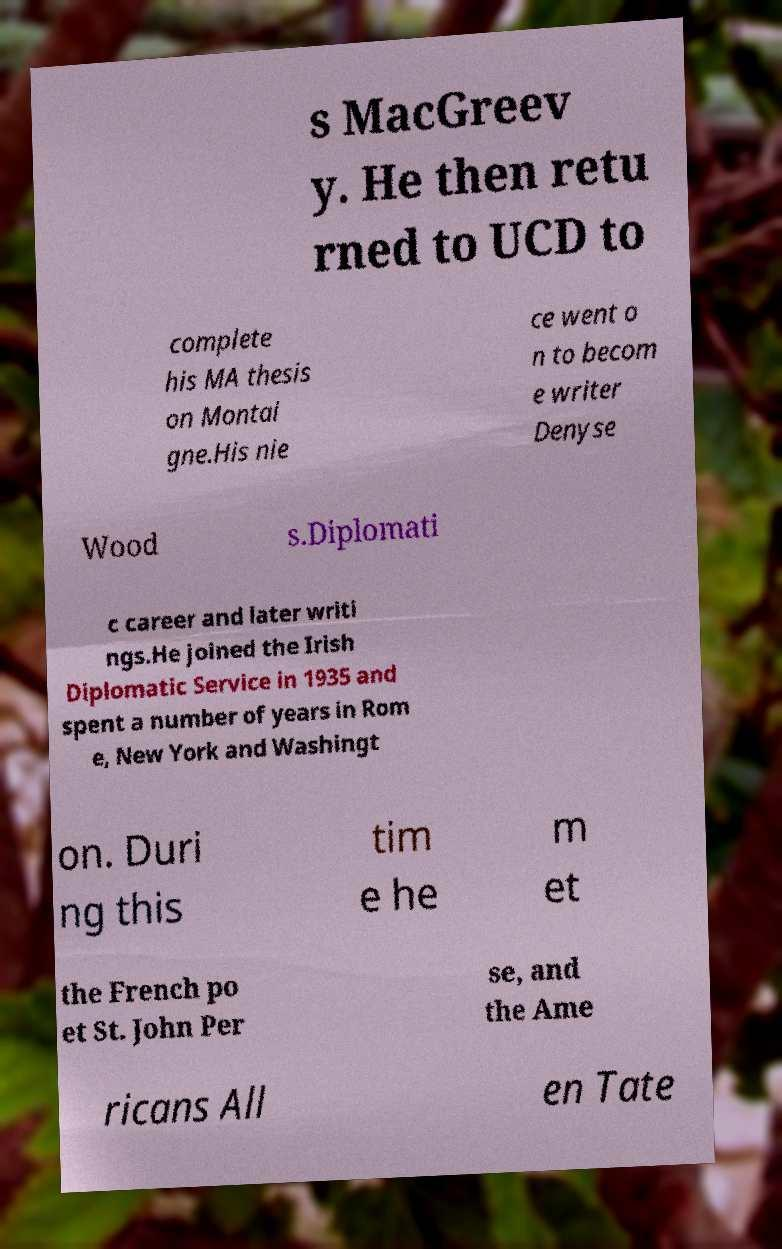Could you extract and type out the text from this image? s MacGreev y. He then retu rned to UCD to complete his MA thesis on Montai gne.His nie ce went o n to becom e writer Denyse Wood s.Diplomati c career and later writi ngs.He joined the Irish Diplomatic Service in 1935 and spent a number of years in Rom e, New York and Washingt on. Duri ng this tim e he m et the French po et St. John Per se, and the Ame ricans All en Tate 